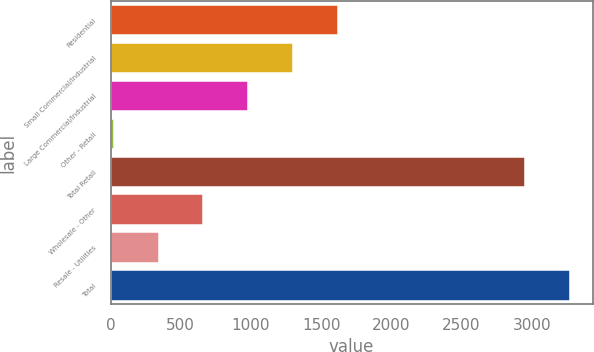<chart> <loc_0><loc_0><loc_500><loc_500><bar_chart><fcel>Residential<fcel>Small Commercial/Industrial<fcel>Large Commercial/Industrial<fcel>Other - Retail<fcel>Total Retail<fcel>Wholesale - Other<fcel>Resale - Utilities<fcel>Total<nl><fcel>1617.1<fcel>1298.26<fcel>979.42<fcel>22.9<fcel>2952.7<fcel>660.58<fcel>341.74<fcel>3271.54<nl></chart> 